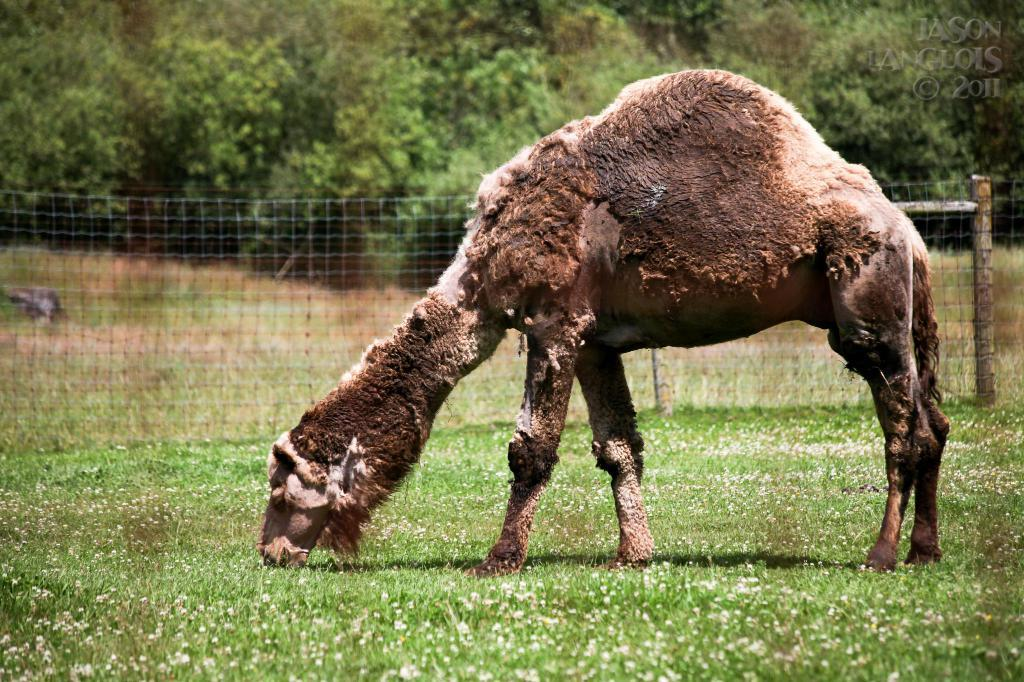What type of animal is in the foreground of the image? The type of animal cannot be determined from the provided facts. What can be seen in the background of the image? There are trees and a net fencing in the background of the image. What type of government is represented by the badge on the animal in the image? There is no badge present on the animal in the image, and therefore no representation of a government can be observed. 